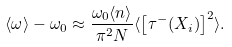<formula> <loc_0><loc_0><loc_500><loc_500>\langle \omega \rangle - \omega _ { 0 } \approx \frac { \omega _ { 0 } \langle n \rangle } { \pi ^ { 2 } N } \langle \left [ \tau ^ { - } ( X _ { i } ) \right ] ^ { 2 } \rangle .</formula> 